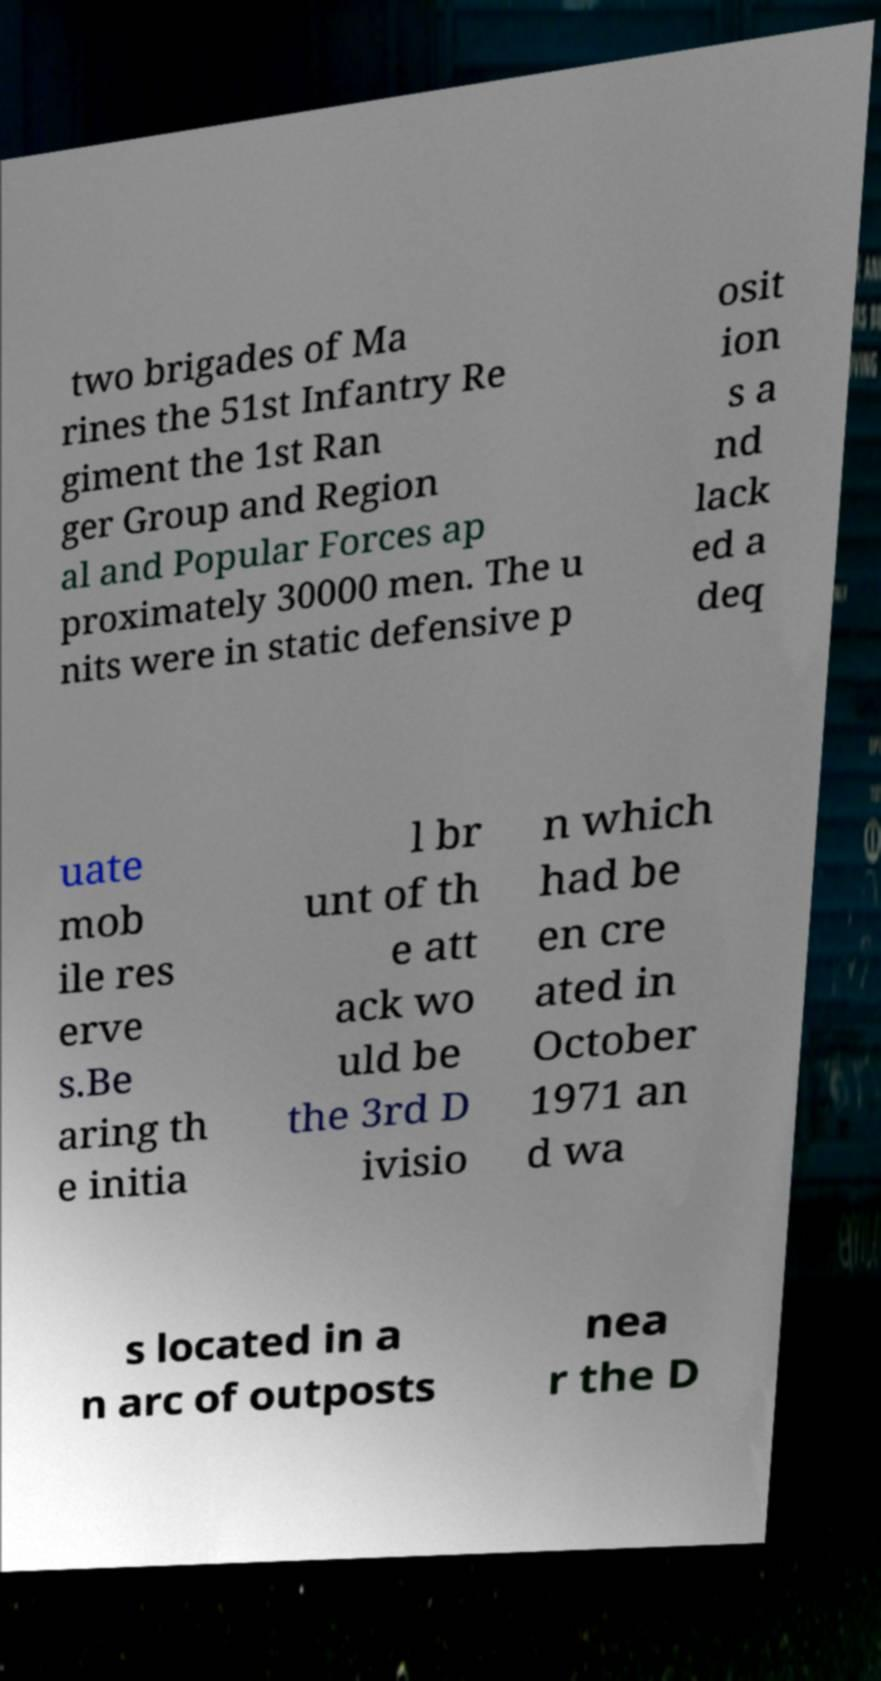Please read and relay the text visible in this image. What does it say? two brigades of Ma rines the 51st Infantry Re giment the 1st Ran ger Group and Region al and Popular Forces ap proximately 30000 men. The u nits were in static defensive p osit ion s a nd lack ed a deq uate mob ile res erve s.Be aring th e initia l br unt of th e att ack wo uld be the 3rd D ivisio n which had be en cre ated in October 1971 an d wa s located in a n arc of outposts nea r the D 